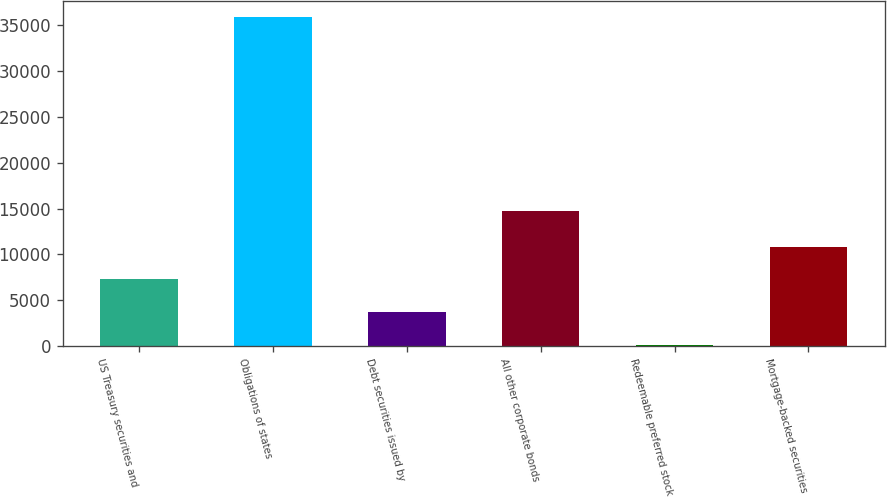Convert chart to OTSL. <chart><loc_0><loc_0><loc_500><loc_500><bar_chart><fcel>US Treasury securities and<fcel>Obligations of states<fcel>Debt securities issued by<fcel>All other corporate bonds<fcel>Redeemable preferred stock<fcel>Mortgage-backed securities<nl><fcel>7274.2<fcel>35907<fcel>3695.1<fcel>14784<fcel>116<fcel>10853.3<nl></chart> 